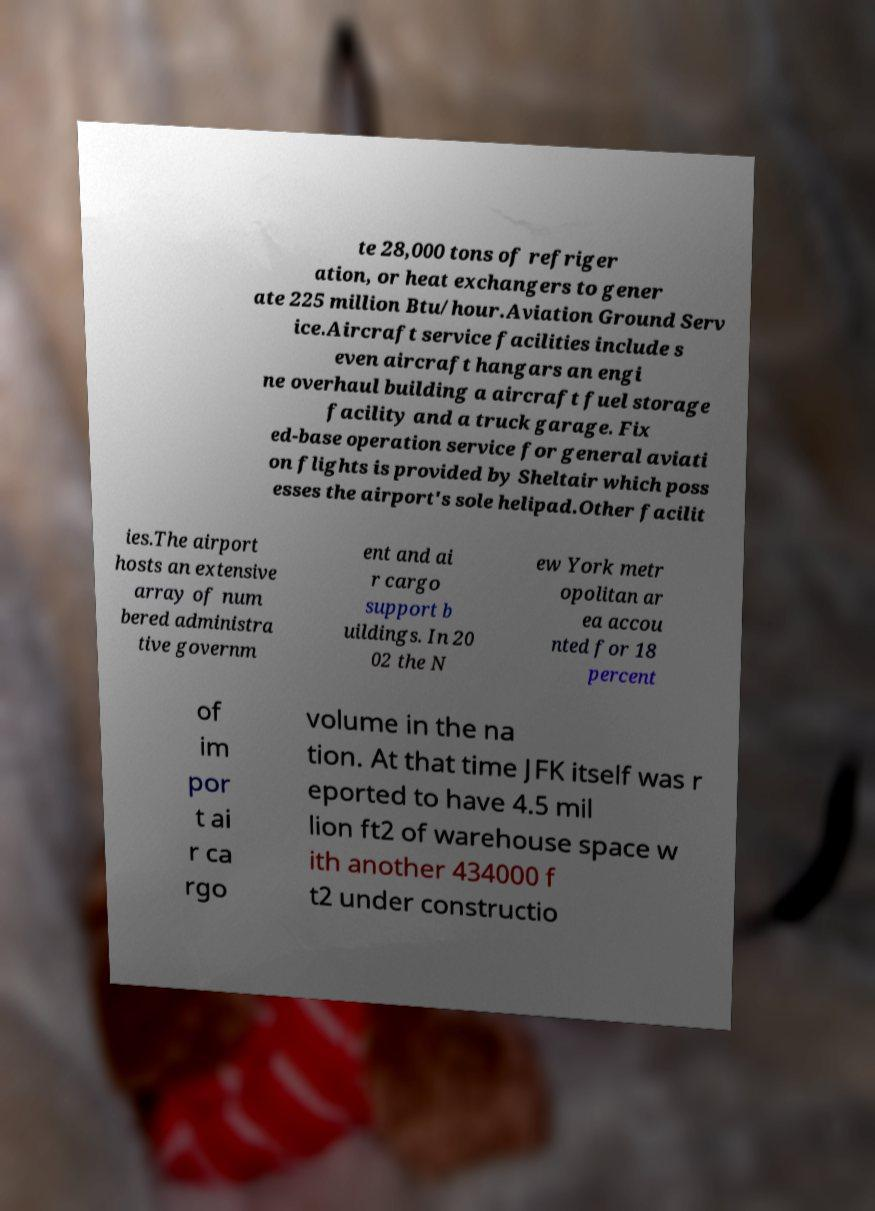What messages or text are displayed in this image? I need them in a readable, typed format. te 28,000 tons of refriger ation, or heat exchangers to gener ate 225 million Btu/hour.Aviation Ground Serv ice.Aircraft service facilities include s even aircraft hangars an engi ne overhaul building a aircraft fuel storage facility and a truck garage. Fix ed-base operation service for general aviati on flights is provided by Sheltair which poss esses the airport's sole helipad.Other facilit ies.The airport hosts an extensive array of num bered administra tive governm ent and ai r cargo support b uildings. In 20 02 the N ew York metr opolitan ar ea accou nted for 18 percent of im por t ai r ca rgo volume in the na tion. At that time JFK itself was r eported to have 4.5 mil lion ft2 of warehouse space w ith another 434000 f t2 under constructio 